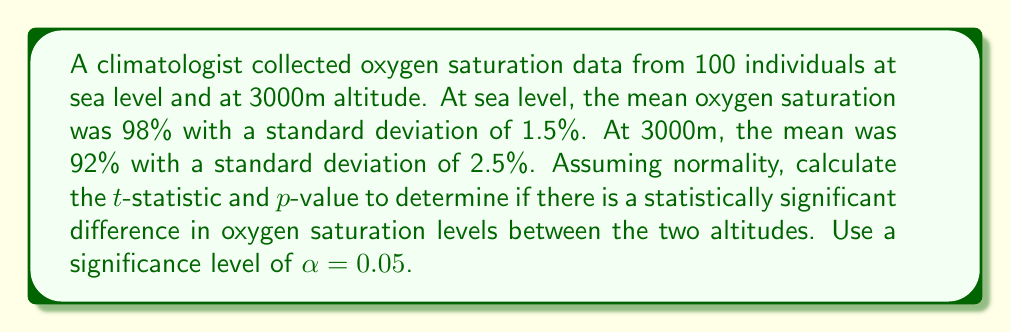Can you answer this question? To determine if there is a statistically significant difference between the two groups, we'll use an independent samples t-test.

Step 1: Calculate the pooled standard error
The pooled standard error (SE) is given by:

$$ SE = \sqrt{\frac{s_1^2}{n_1} + \frac{s_2^2}{n_2}} $$

Where $s_1$ and $s_2$ are the standard deviations, and $n_1$ and $n_2$ are the sample sizes.

$$ SE = \sqrt{\frac{1.5^2}{100} + \frac{2.5^2}{100}} = \sqrt{0.0225 + 0.0625} = \sqrt{0.085} = 0.2915 $$

Step 2: Calculate the t-statistic
The t-statistic is given by:

$$ t = \frac{\bar{x_1} - \bar{x_2}}{SE} $$

Where $\bar{x_1}$ and $\bar{x_2}$ are the sample means.

$$ t = \frac{98 - 92}{0.2915} = \frac{6}{0.2915} = 20.58 $$

Step 3: Calculate the degrees of freedom (df)
$$ df = n_1 + n_2 - 2 = 100 + 100 - 2 = 198 $$

Step 4: Determine the critical t-value
For a two-tailed test with α = 0.05 and df = 198, the critical t-value is approximately ±1.97.

Step 5: Calculate the p-value
Using a t-distribution calculator or table, we find that the p-value for t = 20.58 with df = 198 is p < 0.0001.

Step 6: Compare the p-value to the significance level
Since p < 0.0001 is less than α = 0.05, we reject the null hypothesis.
Answer: t = 20.58, p < 0.0001; statistically significant difference 